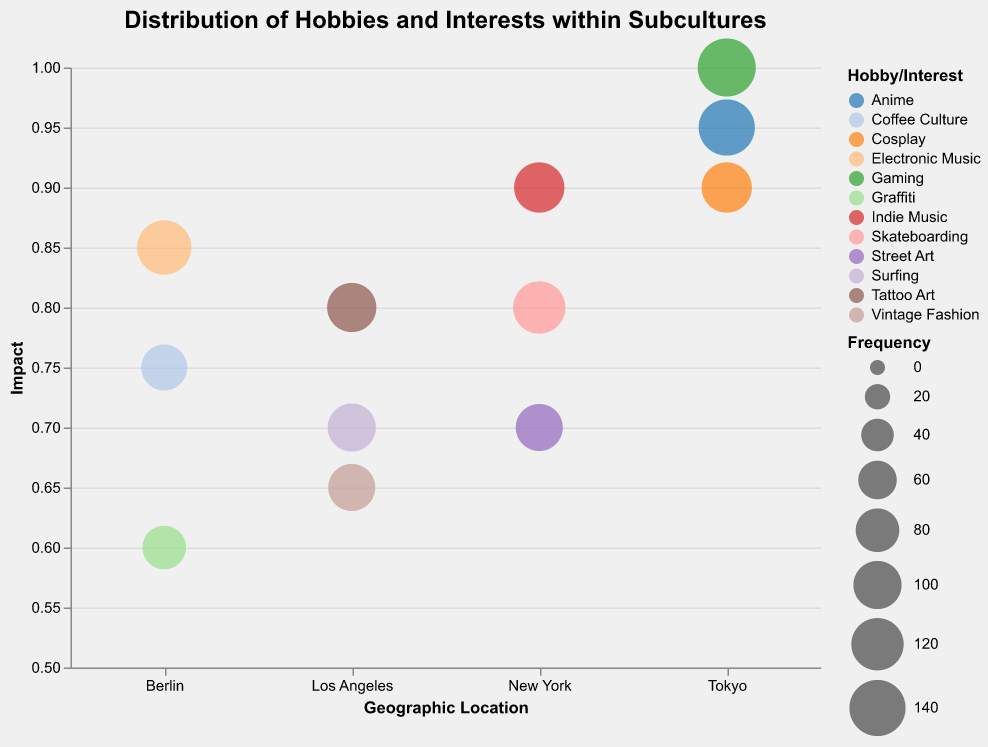What's the title of the chart? The title of the chart can typically be found at the top and is designed to give a brief description of the figure. The title for this chart is "Distribution of Hobbies and Interests within Subcultures".
Answer: Distribution of Hobbies and Interests within Subcultures How many geographic locations are represented in the chart? By observing the x-axis, we can see the different segments denoted as geographic locations. The locations listed are New York, Berlin, Tokyo, and Los Angeles.
Answer: 4 Which hobby in Tokyo has the highest impact score? To determine this, we review the data points in the Tokyo segment and examine the y-axis values for Impact. The highest impact value we see for Tokyo is 1.0, associated with Gaming.
Answer: Gaming What is the frequency of Coffee Culture in Berlin? By looking at the bubble in the Berlin segment for Coffee Culture, we can check the associated tooltip or visual size which corresponds to Frequency. The value is provided as 90.
Answer: 90 Compare the impacts of Skateboarding in New York and Surfing in Los Angeles. Which has a higher impact? We need to compare the y-axis values for Skateboarding in New York (0.8) and Surfing in Los Angeles (0.7). Skateboarding, with an impact of 0.8, is higher.
Answer: Skateboarding How many hobbies have an impact higher than 0.9? We count the bubbles with a y-value (Impact) greater than 0.9. The hobbies meeting this criterion are Indie Music (New York), Anime (Tokyo), Cosplay (Tokyo), and Gaming (Tokyo). Thus, there are 4.
Answer: 4 What is the total frequency of all hobbies in New York? We sum up the frequencies of all hobbies in New York: Skateboarding (120) + Street Art (95) + Indie Music (110). The total is 325.
Answer: 325 Which city has the largest bubble, and what hobby does it represent? The size of the bubble corresponds to the frequency, with the largest bubble having the highest frequency value. Observing the chart, the largest bubble appears in Tokyo for Gaming, with a frequency of 150.
Answer: Tokyo, Gaming Which has a greater frequency, Electronic Music in Berlin or Tattoo Art in Los Angeles? Checking the size of the bubbles or the frequency values, Electronic Music in Berlin has a frequency of 130, while Tattoo Art in Los Angeles has a frequency of 105. Thus, Electronic Music in Berlin has the greater frequency.
Answer: Electronic Music What is the average impact of hobbies in Los Angeles? To calculate this, we sum the impact values for all hobbies in Los Angeles and divide by the number of hobbies: (Surfing 0.7 + Tattoo Art 0.8 + Vintage Fashion 0.65) / 3. The total is 2.15 / 3, which equals 0.7167.
Answer: 0.72 